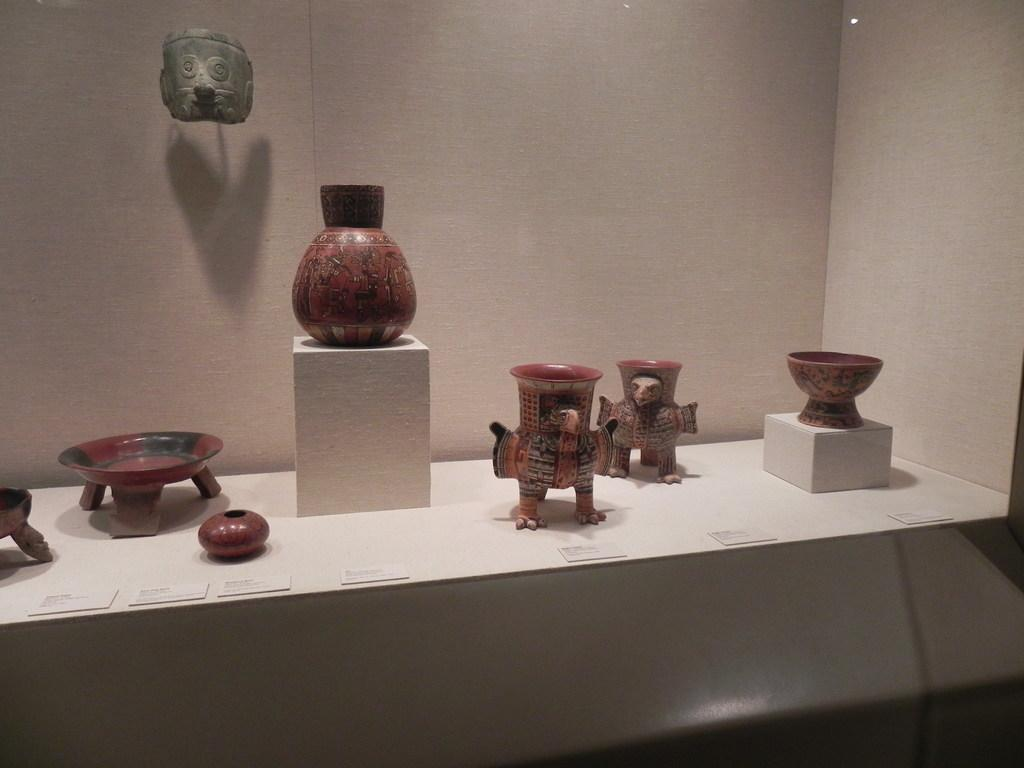What objects can be seen on the table in the image? There are artifacts and name boards placed on the table. What is visible in the background of the image? There is a wall in the backdrop of the image. What type of sock is being played on the instrument in the image? There is no sock or instrument present in the image. How many arms are visible in the image? There are no arms visible in the image. 